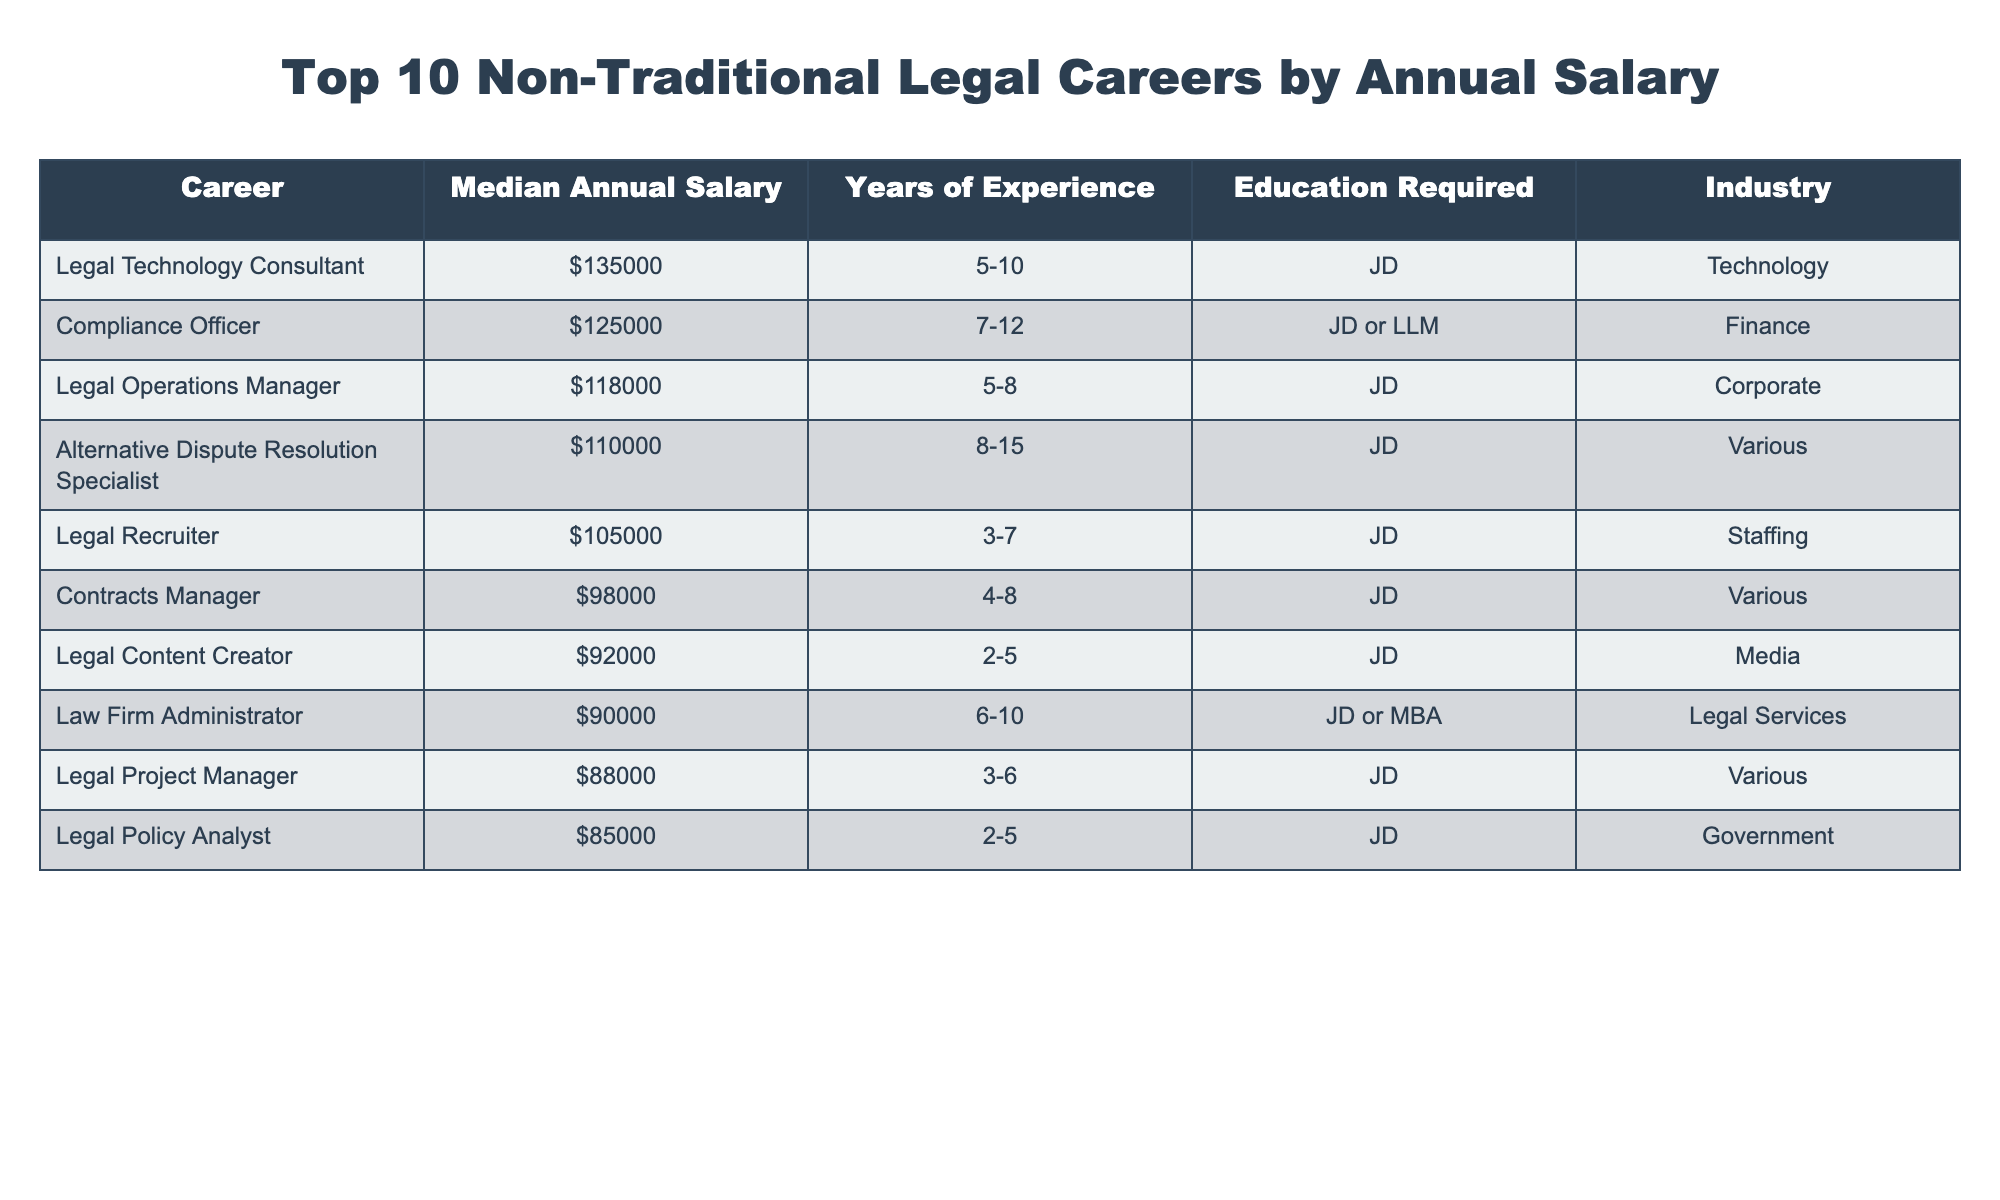What is the highest median annual salary among the listed careers? By examining the 'Median Annual Salary' column, the highest value is $135,000, which corresponds to the role of Legal Technology Consultant.
Answer: $135,000 How many years of experience is required for a Legal Recruiter? Looking at the 'Years of Experience' column related to the Legal Recruiter position, it specifies between 3 to 7 years of experience.
Answer: 3-7 years Is a JD required for all the careers listed? Reviewing the 'Education Required' column, it shows that not all positions strictly require a JD; for instance, a Law Firm Administrator can also have an MBA.
Answer: No What is the average median annual salary of the top three careers listed? The top three median salaries are $135,000 (Legal Technology Consultant), $125,000 (Compliance Officer), and $118,000 (Legal Operations Manager). Adding these gives $378,000, and dividing by 3 gives an average of $126,000.
Answer: $126,000 What is the difference in salary between a Compliance Officer and a Legal Policy Analyst? The salary for a Compliance Officer is $125,000 and for a Legal Policy Analyst is $85,000. Calculating the difference ($125,000 - $85,000) equals $40,000.
Answer: $40,000 Which career requires the highest level of education, and what is that requirement? Upon inspecting the table, the career of Compliance Officer typically requires an LLM in addition to a JD, which represents the highest level of education mentioned.
Answer: Compliance Officer; JD or LLM How many years of experience is the average for the top five careers listed? The years of experience for the top five careers are 5-10, 7-12, 5-8, 8-15, and 3-7. Taking the average of these ranges gives an estimated average of (7.5 + 9.5 + 6.5 + 11.5 + 5)/5 = 8.2 years.
Answer: Approximately 8.2 years What percentage of the careers listed require at least eight years of experience? Out of the ten careers, four of them require at least 8 years of experience (Compliance Officer, Alternative Dispute Resolution Specialist, Contracts Manager, and Legal Operations Manager). Thus, the calculation is (4/10)*100 = 40%.
Answer: 40% Is it true that Legal Content Creator has the lowest median annual salary among these careers? Comparing the ‘Median Annual Salary’ column, Legal Content Creator's median salary of $92,000 is indeed the lowest among the listed careers.
Answer: Yes Which career in the table requires the least years of experience? Looking at the 'Years of Experience' column, Legal Content Creator requires the least experience, at 2-5 years.
Answer: Legal Content Creator (2-5 years) 